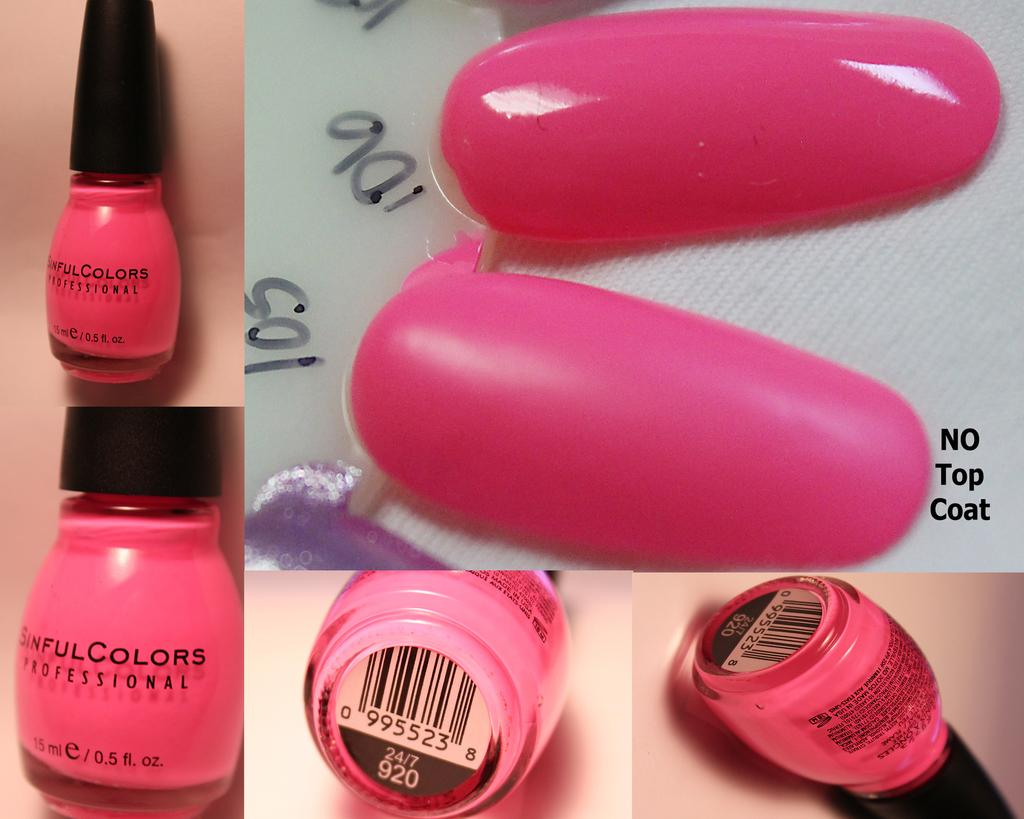<image>
Offer a succinct explanation of the picture presented. Pictures of a nail polish bottle that says Sinful Colors at different angles with nails painted pink. 